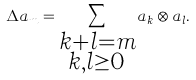Convert formula to latex. <formula><loc_0><loc_0><loc_500><loc_500>\Delta a _ { m } = \sum _ { \substack { k + l = m \\ k , l \geq 0 } } a _ { k } \otimes a _ { l } .</formula> 